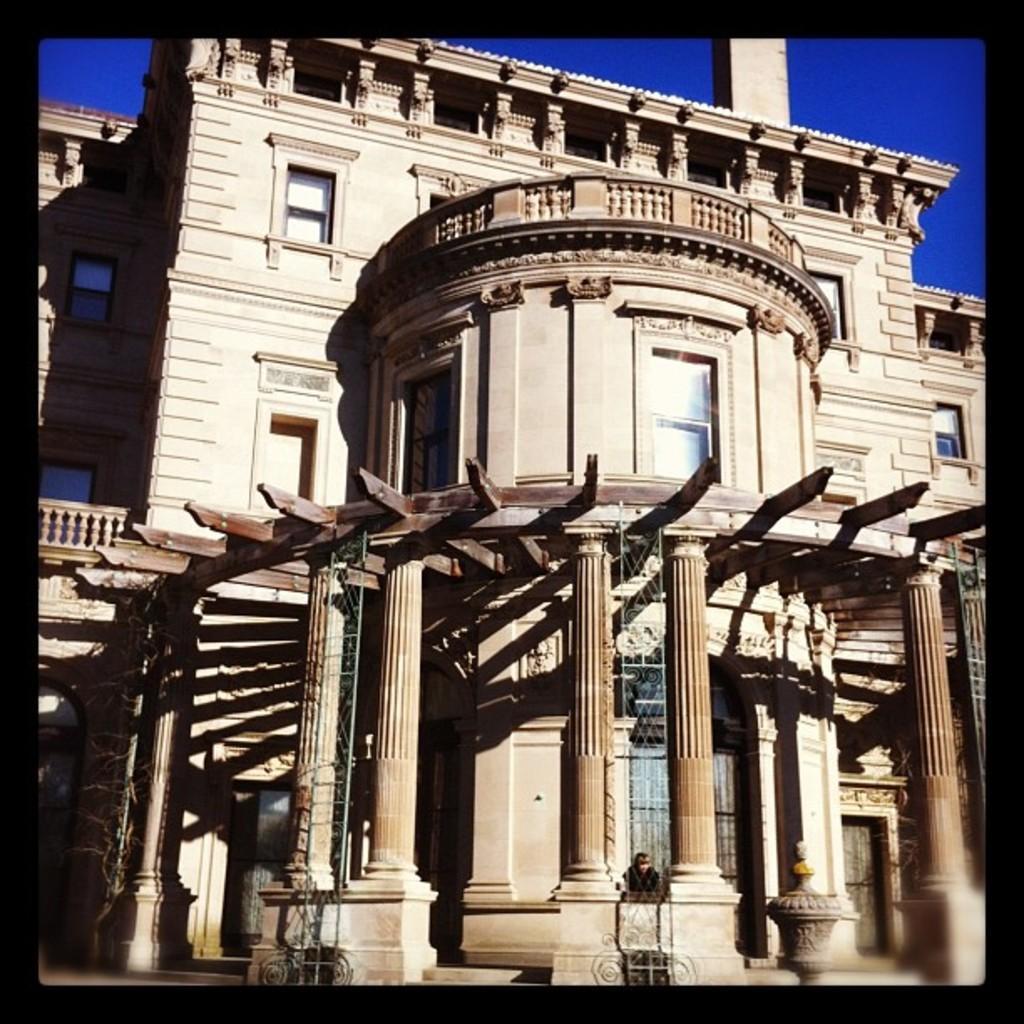How would you summarize this image in a sentence or two? In this image I can see a building which is cream and brown in color. I can see few windows of the building and in the background I can see the sky which is blue in color. 